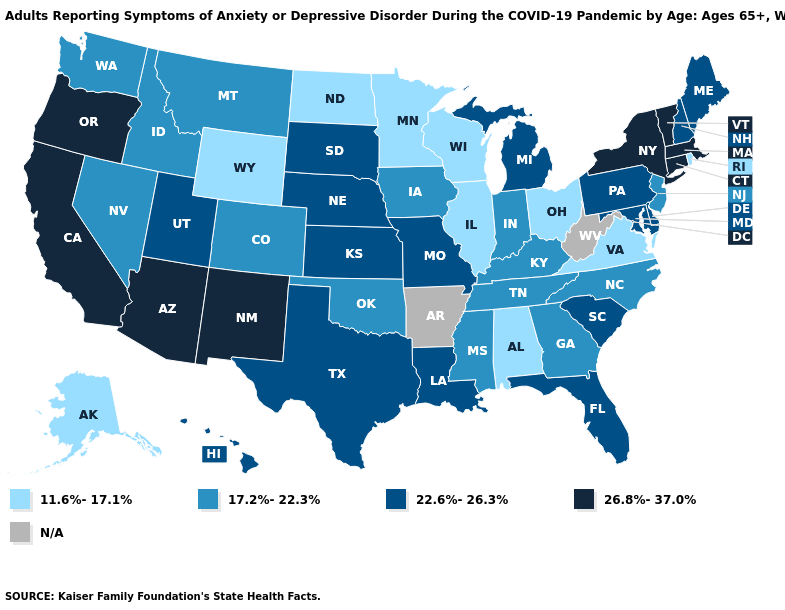Is the legend a continuous bar?
Quick response, please. No. Which states have the lowest value in the MidWest?
Give a very brief answer. Illinois, Minnesota, North Dakota, Ohio, Wisconsin. How many symbols are there in the legend?
Quick response, please. 5. What is the value of Maryland?
Short answer required. 22.6%-26.3%. Name the states that have a value in the range 17.2%-22.3%?
Keep it brief. Colorado, Georgia, Idaho, Indiana, Iowa, Kentucky, Mississippi, Montana, Nevada, New Jersey, North Carolina, Oklahoma, Tennessee, Washington. Does New Mexico have the highest value in the USA?
Answer briefly. Yes. How many symbols are there in the legend?
Write a very short answer. 5. Name the states that have a value in the range 22.6%-26.3%?
Keep it brief. Delaware, Florida, Hawaii, Kansas, Louisiana, Maine, Maryland, Michigan, Missouri, Nebraska, New Hampshire, Pennsylvania, South Carolina, South Dakota, Texas, Utah. What is the value of Rhode Island?
Write a very short answer. 11.6%-17.1%. What is the lowest value in states that border Utah?
Give a very brief answer. 11.6%-17.1%. Name the states that have a value in the range 26.8%-37.0%?
Write a very short answer. Arizona, California, Connecticut, Massachusetts, New Mexico, New York, Oregon, Vermont. What is the value of New Jersey?
Write a very short answer. 17.2%-22.3%. 